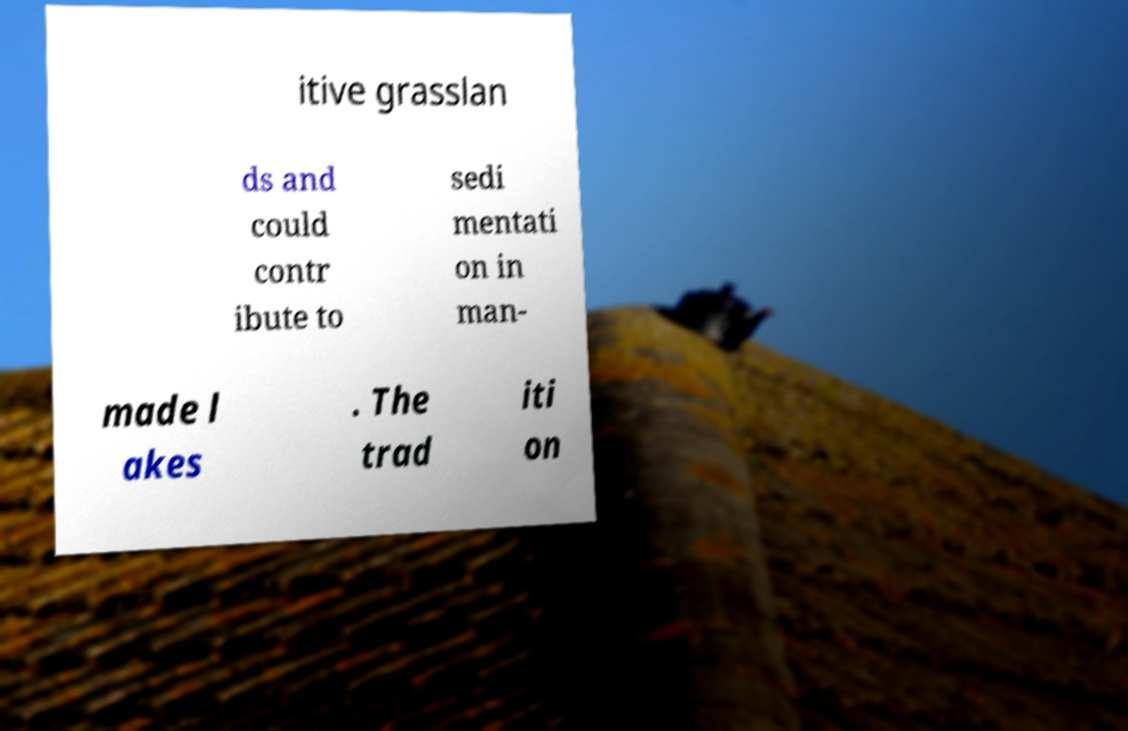Could you assist in decoding the text presented in this image and type it out clearly? itive grasslan ds and could contr ibute to sedi mentati on in man- made l akes . The trad iti on 